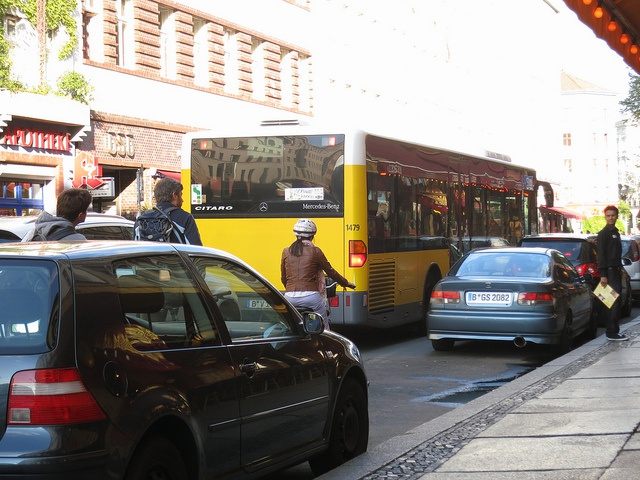Describe the objects in this image and their specific colors. I can see car in olive, black, gray, maroon, and blue tones, bus in olive, black, gray, gold, and white tones, car in olive, black, gray, blue, and lightblue tones, people in olive, gray, maroon, and black tones, and people in olive, black, gray, and maroon tones in this image. 